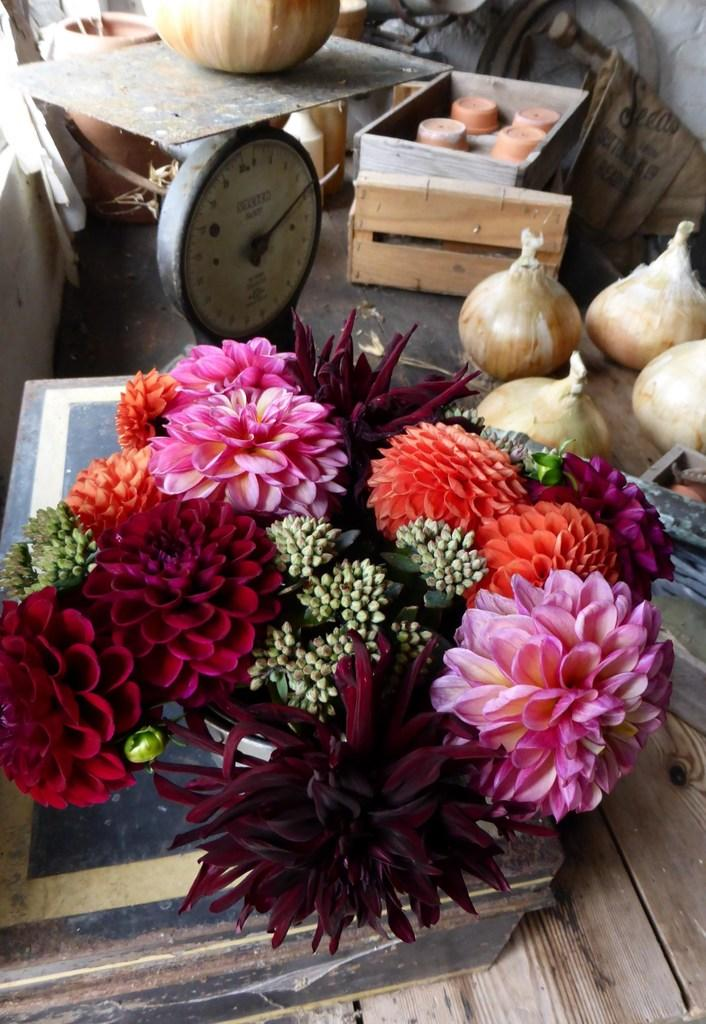What is the main subject in the center of the image? There are colorful flowers in the center of the image. What can be seen on the right side of the image? There are onions on the right side of the image. What type of containers are visible at the top side of the image? There are wooden boxes at the top side of the image. What advice does the father give about the friction between the flowers and onions in the image? There is no father or friction between the flowers and onions in the image, as the image only contains flowers, onions, and wooden boxes. 